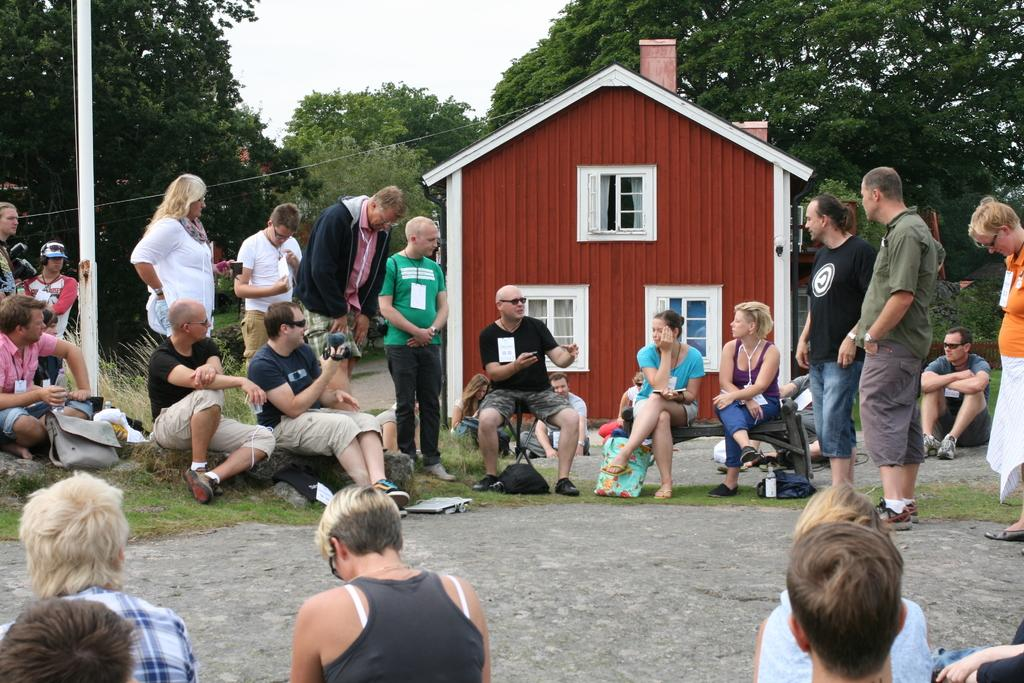How many people are in the image? There is a group of people in the image, but the exact number cannot be determined from the provided facts. What are the people in the image doing? Some people are standing, while others are sitting. What can be seen in the background of the image? There are trees in the backdrop of the image. What is located at the left side of the image? There is a pole at the left side of the image. What is the condition of the sky in the image? The sky is clear in the image. What type of ray is visible in the image? There is no ray present in the image. Is there a locket hanging from the pole in the image? There is no mention of a locket in the provided facts, and therefore we cannot determine if one is present. 